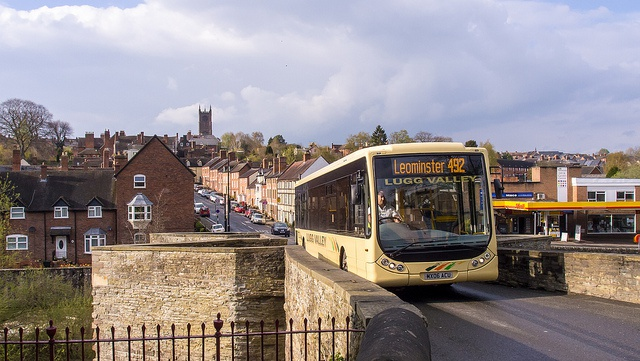Describe the objects in this image and their specific colors. I can see bus in lavender, black, gray, and khaki tones, people in lavender, gray, darkgray, and black tones, car in lavender, black, gray, and darkgray tones, car in lavender, gray, darkgray, lightgray, and black tones, and car in lavender, darkgray, gray, and black tones in this image. 